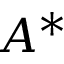<formula> <loc_0><loc_0><loc_500><loc_500>A ^ { * }</formula> 